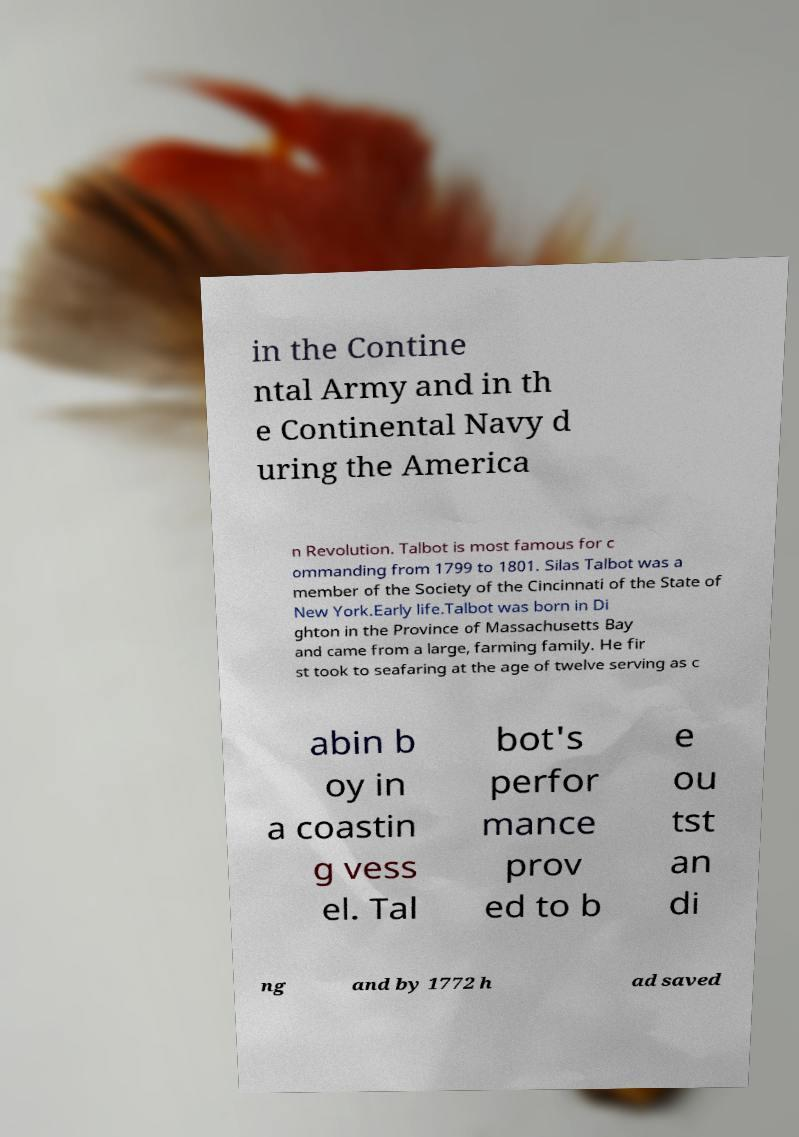Please read and relay the text visible in this image. What does it say? in the Contine ntal Army and in th e Continental Navy d uring the America n Revolution. Talbot is most famous for c ommanding from 1799 to 1801. Silas Talbot was a member of the Society of the Cincinnati of the State of New York.Early life.Talbot was born in Di ghton in the Province of Massachusetts Bay and came from a large, farming family. He fir st took to seafaring at the age of twelve serving as c abin b oy in a coastin g vess el. Tal bot's perfor mance prov ed to b e ou tst an di ng and by 1772 h ad saved 